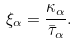Convert formula to latex. <formula><loc_0><loc_0><loc_500><loc_500>\xi _ { \alpha } = \frac { \kappa _ { \alpha } } { \bar { \tau } _ { \alpha } } .</formula> 